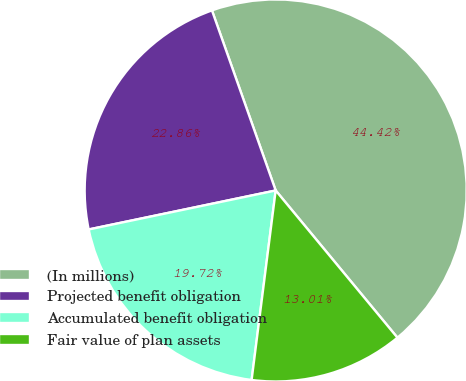<chart> <loc_0><loc_0><loc_500><loc_500><pie_chart><fcel>(In millions)<fcel>Projected benefit obligation<fcel>Accumulated benefit obligation<fcel>Fair value of plan assets<nl><fcel>44.42%<fcel>22.86%<fcel>19.72%<fcel>13.01%<nl></chart> 